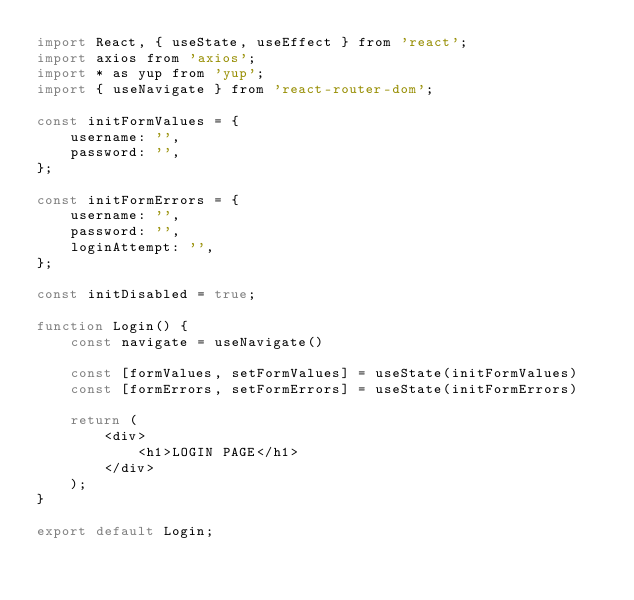Convert code to text. <code><loc_0><loc_0><loc_500><loc_500><_JavaScript_>import React, { useState, useEffect } from 'react';
import axios from 'axios';
import * as yup from 'yup';
import { useNavigate } from 'react-router-dom';

const initFormValues = {
	username: '',
	password: '',
};

const initFormErrors = {
	username: '',
	password: '',
	loginAttempt: '',
};

const initDisabled = true;

function Login() {
    const navigate = useNavigate()

    const [formValues, setFormValues] = useState(initFormValues)
    const [formErrors, setFormErrors] = useState(initFormErrors)
    
	return (
		<div>
			<h1>LOGIN PAGE</h1>
		</div>
	);
}

export default Login;
</code> 